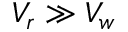Convert formula to latex. <formula><loc_0><loc_0><loc_500><loc_500>V _ { r } \gg V _ { w }</formula> 